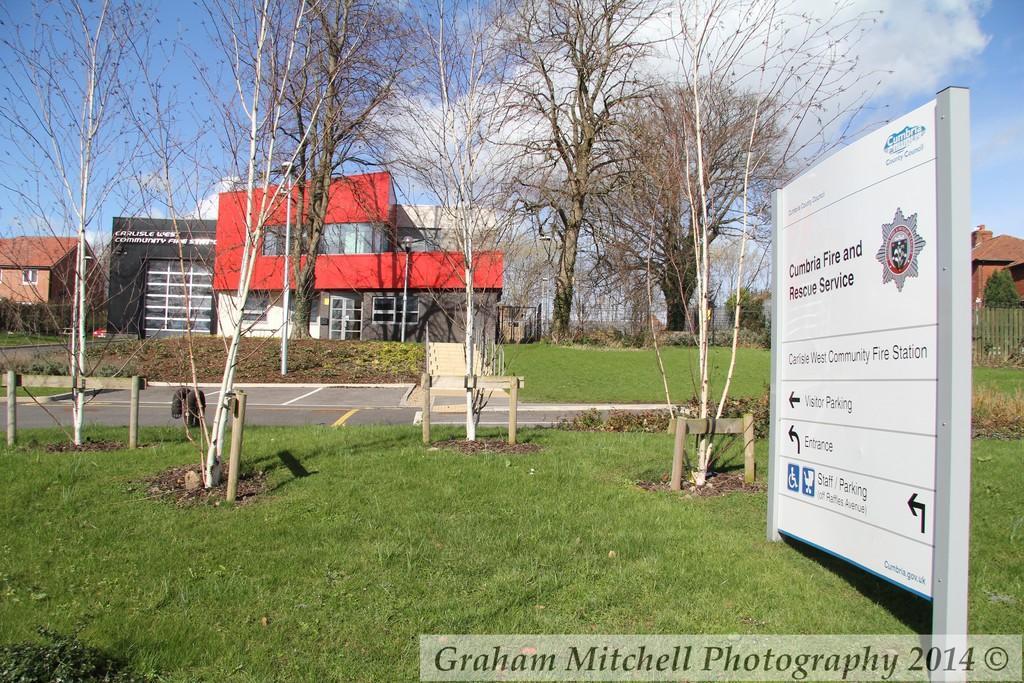Describe this image in one or two sentences. In this image I can see the white color board and something is written on it. To the side of the board I can see many trees and the road. In the background there are many buildings, clouds and the blue sky. 